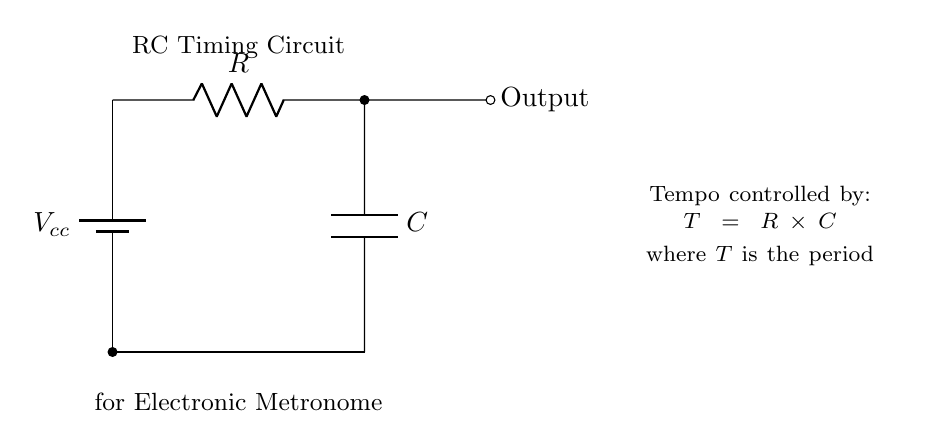What type of circuit is this? This circuit is an RC timing circuit, which is specifically designed to control time intervals using a resistor and capacitor. The labeling in the circuit diagram indicates its purpose for tempo control in an electronic metronome.
Answer: RC timing circuit What is the role of the resistor in this circuit? The resistor in an RC circuit affects the charging and discharging time of the capacitor, which is crucial for controlling the timing interval (or period) of oscillation in the electronic metronome.
Answer: Controls timing What is the relationship between resistance, capacitance, and the period? The formula provided in the diagram defines the relationship: the period (T) is equal to the product of the resistance (R) and capacitance (C). This simple formula allows adjustments in tempo by modifying either R or C.
Answer: T = R × C What happens to the period if the resistance is doubled? Doubling the resistance (R) will also double the period (T), because according to the formula, any increase in R will proportionally increase T, given that capacitance remains constant.
Answer: Period doubles What is the output in this RC timing circuit? The output is a signal that corresponds to the timing intervals set by the values of R and C, which can be interpreted as beats in the context of a metronome. This output will likely be a square wave indicating each tempo beat.
Answer: Signal at Output What components are in this circuit? The circuit consists of a resistor (R) and a capacitor (C), along with a voltage source (Vcc) and an output point, all crucial for forming the RC timing mechanism.
Answer: Resistor and Capacitor 